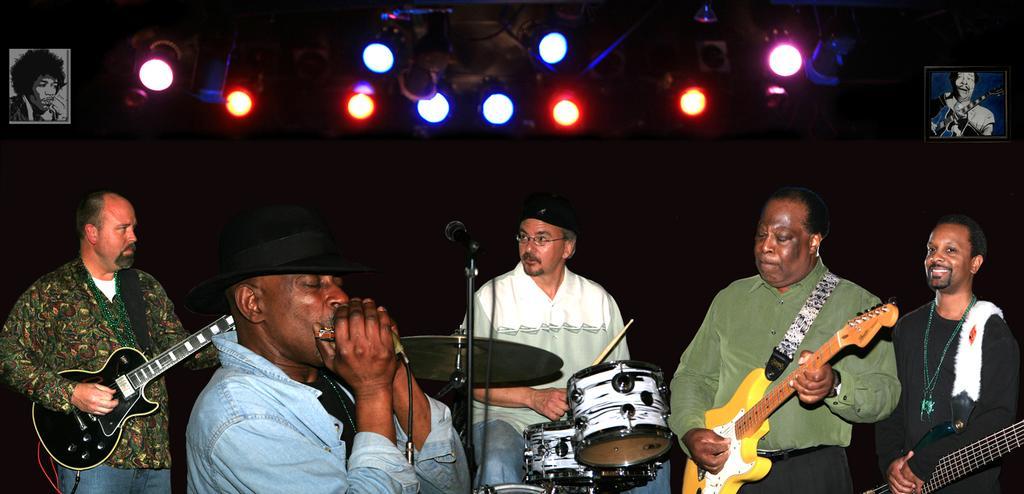In one or two sentences, can you explain what this image depicts? There is a group of people. They are standing and playing a musical instruments. On the right side of the person is smiling. We can see in the background posters and lightnings. 